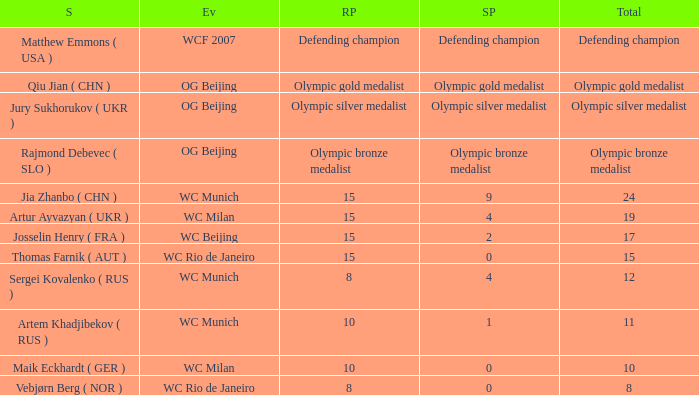With Olympic Bronze Medalist as the total what are the score points? Olympic bronze medalist. 